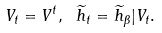<formula> <loc_0><loc_0><loc_500><loc_500>V _ { t } = V ^ { t } , \ \widetilde { h } _ { t } = \widetilde { h } _ { \beta } | { V _ { t } } .</formula> 